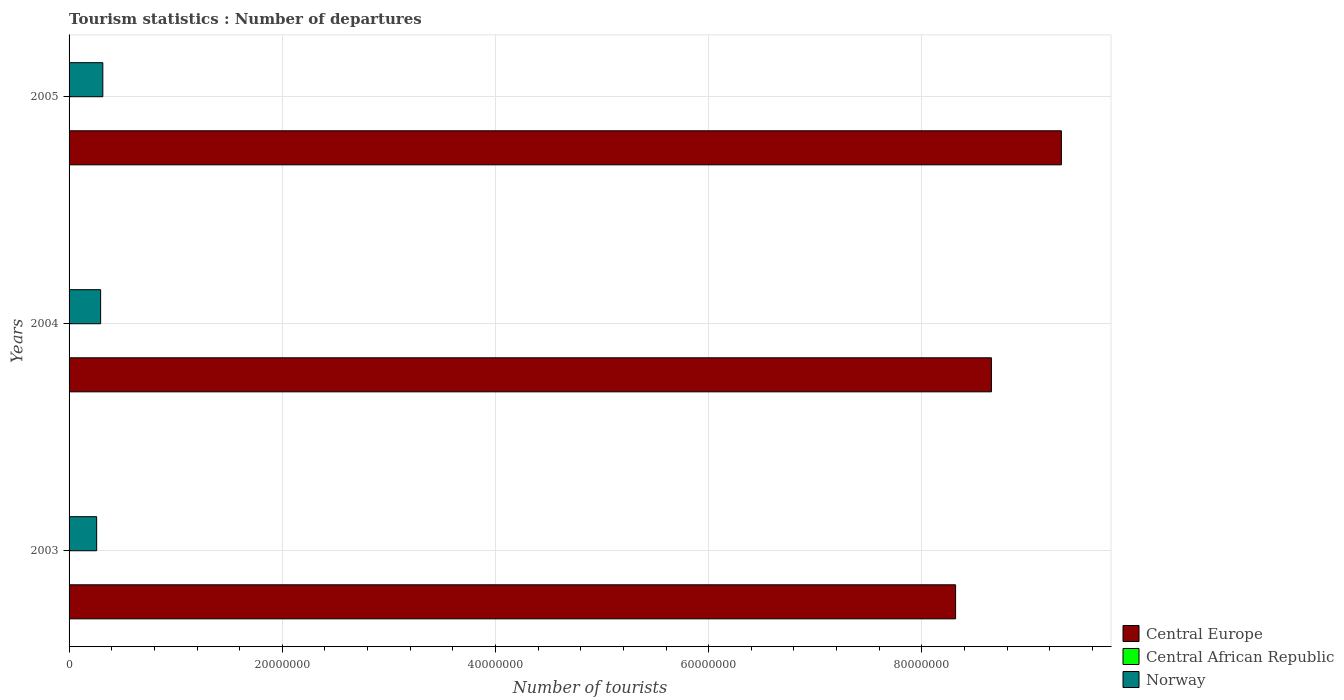Are the number of bars per tick equal to the number of legend labels?
Give a very brief answer. Yes. How many bars are there on the 3rd tick from the bottom?
Keep it short and to the point. 3. What is the label of the 3rd group of bars from the top?
Provide a succinct answer. 2003. In how many cases, is the number of bars for a given year not equal to the number of legend labels?
Your answer should be compact. 0. What is the number of tourist departures in Norway in 2005?
Give a very brief answer. 3.17e+06. Across all years, what is the maximum number of tourist departures in Central Europe?
Ensure brevity in your answer.  9.31e+07. Across all years, what is the minimum number of tourist departures in Central African Republic?
Your answer should be very brief. 6000. What is the total number of tourist departures in Norway in the graph?
Your response must be concise. 8.71e+06. What is the difference between the number of tourist departures in Central Europe in 2004 and that in 2005?
Offer a very short reply. -6.56e+06. What is the difference between the number of tourist departures in Central Europe in 2004 and the number of tourist departures in Central African Republic in 2003?
Your response must be concise. 8.65e+07. What is the average number of tourist departures in Central Europe per year?
Provide a short and direct response. 8.76e+07. In the year 2005, what is the difference between the number of tourist departures in Norway and number of tourist departures in Central Europe?
Provide a short and direct response. -8.99e+07. In how many years, is the number of tourist departures in Norway greater than 80000000 ?
Offer a terse response. 0. Is the number of tourist departures in Central African Republic in 2004 less than that in 2005?
Make the answer very short. Yes. What is the difference between the highest and the second highest number of tourist departures in Norway?
Ensure brevity in your answer.  2.06e+05. What is the difference between the highest and the lowest number of tourist departures in Central Europe?
Provide a succinct answer. 9.92e+06. What does the 2nd bar from the bottom in 2004 represents?
Offer a very short reply. Central African Republic. Is it the case that in every year, the sum of the number of tourist departures in Central Europe and number of tourist departures in Norway is greater than the number of tourist departures in Central African Republic?
Your answer should be very brief. Yes. How many bars are there?
Make the answer very short. 9. Are all the bars in the graph horizontal?
Provide a short and direct response. Yes. How many years are there in the graph?
Your response must be concise. 3. Are the values on the major ticks of X-axis written in scientific E-notation?
Your answer should be compact. No. Where does the legend appear in the graph?
Offer a terse response. Bottom right. What is the title of the graph?
Your answer should be very brief. Tourism statistics : Number of departures. Does "Guam" appear as one of the legend labels in the graph?
Provide a succinct answer. No. What is the label or title of the X-axis?
Offer a terse response. Number of tourists. What is the label or title of the Y-axis?
Provide a succinct answer. Years. What is the Number of tourists of Central Europe in 2003?
Ensure brevity in your answer.  8.32e+07. What is the Number of tourists of Central African Republic in 2003?
Provide a short and direct response. 6000. What is the Number of tourists of Norway in 2003?
Offer a very short reply. 2.59e+06. What is the Number of tourists of Central Europe in 2004?
Your answer should be very brief. 8.65e+07. What is the Number of tourists of Central African Republic in 2004?
Offer a very short reply. 7000. What is the Number of tourists of Norway in 2004?
Ensure brevity in your answer.  2.96e+06. What is the Number of tourists in Central Europe in 2005?
Your response must be concise. 9.31e+07. What is the Number of tourists of Central African Republic in 2005?
Your answer should be compact. 8000. What is the Number of tourists of Norway in 2005?
Provide a short and direct response. 3.17e+06. Across all years, what is the maximum Number of tourists in Central Europe?
Ensure brevity in your answer.  9.31e+07. Across all years, what is the maximum Number of tourists of Central African Republic?
Your answer should be compact. 8000. Across all years, what is the maximum Number of tourists in Norway?
Provide a succinct answer. 3.17e+06. Across all years, what is the minimum Number of tourists in Central Europe?
Your answer should be compact. 8.32e+07. Across all years, what is the minimum Number of tourists in Central African Republic?
Offer a terse response. 6000. Across all years, what is the minimum Number of tourists of Norway?
Ensure brevity in your answer.  2.59e+06. What is the total Number of tourists of Central Europe in the graph?
Your response must be concise. 2.63e+08. What is the total Number of tourists of Central African Republic in the graph?
Offer a terse response. 2.10e+04. What is the total Number of tourists of Norway in the graph?
Provide a short and direct response. 8.71e+06. What is the difference between the Number of tourists of Central Europe in 2003 and that in 2004?
Your response must be concise. -3.36e+06. What is the difference between the Number of tourists of Central African Republic in 2003 and that in 2004?
Offer a terse response. -1000. What is the difference between the Number of tourists of Norway in 2003 and that in 2004?
Offer a terse response. -3.72e+05. What is the difference between the Number of tourists of Central Europe in 2003 and that in 2005?
Offer a very short reply. -9.92e+06. What is the difference between the Number of tourists of Central African Republic in 2003 and that in 2005?
Give a very brief answer. -2000. What is the difference between the Number of tourists in Norway in 2003 and that in 2005?
Make the answer very short. -5.78e+05. What is the difference between the Number of tourists of Central Europe in 2004 and that in 2005?
Provide a succinct answer. -6.56e+06. What is the difference between the Number of tourists of Central African Republic in 2004 and that in 2005?
Your answer should be very brief. -1000. What is the difference between the Number of tourists in Norway in 2004 and that in 2005?
Offer a very short reply. -2.06e+05. What is the difference between the Number of tourists in Central Europe in 2003 and the Number of tourists in Central African Republic in 2004?
Your answer should be compact. 8.32e+07. What is the difference between the Number of tourists of Central Europe in 2003 and the Number of tourists of Norway in 2004?
Your response must be concise. 8.02e+07. What is the difference between the Number of tourists of Central African Republic in 2003 and the Number of tourists of Norway in 2004?
Your answer should be very brief. -2.95e+06. What is the difference between the Number of tourists in Central Europe in 2003 and the Number of tourists in Central African Republic in 2005?
Give a very brief answer. 8.32e+07. What is the difference between the Number of tourists in Central Europe in 2003 and the Number of tourists in Norway in 2005?
Offer a terse response. 8.00e+07. What is the difference between the Number of tourists of Central African Republic in 2003 and the Number of tourists of Norway in 2005?
Offer a terse response. -3.16e+06. What is the difference between the Number of tourists of Central Europe in 2004 and the Number of tourists of Central African Republic in 2005?
Your answer should be very brief. 8.65e+07. What is the difference between the Number of tourists of Central Europe in 2004 and the Number of tourists of Norway in 2005?
Your response must be concise. 8.34e+07. What is the difference between the Number of tourists of Central African Republic in 2004 and the Number of tourists of Norway in 2005?
Ensure brevity in your answer.  -3.16e+06. What is the average Number of tourists of Central Europe per year?
Give a very brief answer. 8.76e+07. What is the average Number of tourists in Central African Republic per year?
Offer a very short reply. 7000. What is the average Number of tourists of Norway per year?
Provide a short and direct response. 2.90e+06. In the year 2003, what is the difference between the Number of tourists in Central Europe and Number of tourists in Central African Republic?
Your response must be concise. 8.32e+07. In the year 2003, what is the difference between the Number of tourists in Central Europe and Number of tourists in Norway?
Offer a terse response. 8.06e+07. In the year 2003, what is the difference between the Number of tourists in Central African Republic and Number of tourists in Norway?
Your answer should be compact. -2.58e+06. In the year 2004, what is the difference between the Number of tourists of Central Europe and Number of tourists of Central African Republic?
Your response must be concise. 8.65e+07. In the year 2004, what is the difference between the Number of tourists in Central Europe and Number of tourists in Norway?
Your answer should be very brief. 8.36e+07. In the year 2004, what is the difference between the Number of tourists in Central African Republic and Number of tourists in Norway?
Offer a terse response. -2.95e+06. In the year 2005, what is the difference between the Number of tourists in Central Europe and Number of tourists in Central African Republic?
Provide a short and direct response. 9.31e+07. In the year 2005, what is the difference between the Number of tourists of Central Europe and Number of tourists of Norway?
Your answer should be very brief. 8.99e+07. In the year 2005, what is the difference between the Number of tourists in Central African Republic and Number of tourists in Norway?
Keep it short and to the point. -3.16e+06. What is the ratio of the Number of tourists of Central Europe in 2003 to that in 2004?
Offer a very short reply. 0.96. What is the ratio of the Number of tourists in Central African Republic in 2003 to that in 2004?
Ensure brevity in your answer.  0.86. What is the ratio of the Number of tourists in Norway in 2003 to that in 2004?
Ensure brevity in your answer.  0.87. What is the ratio of the Number of tourists of Central Europe in 2003 to that in 2005?
Keep it short and to the point. 0.89. What is the ratio of the Number of tourists in Central African Republic in 2003 to that in 2005?
Give a very brief answer. 0.75. What is the ratio of the Number of tourists in Norway in 2003 to that in 2005?
Provide a short and direct response. 0.82. What is the ratio of the Number of tourists in Central Europe in 2004 to that in 2005?
Your response must be concise. 0.93. What is the ratio of the Number of tourists of Norway in 2004 to that in 2005?
Offer a terse response. 0.93. What is the difference between the highest and the second highest Number of tourists in Central Europe?
Make the answer very short. 6.56e+06. What is the difference between the highest and the second highest Number of tourists in Central African Republic?
Your response must be concise. 1000. What is the difference between the highest and the second highest Number of tourists in Norway?
Keep it short and to the point. 2.06e+05. What is the difference between the highest and the lowest Number of tourists of Central Europe?
Give a very brief answer. 9.92e+06. What is the difference between the highest and the lowest Number of tourists in Central African Republic?
Ensure brevity in your answer.  2000. What is the difference between the highest and the lowest Number of tourists in Norway?
Keep it short and to the point. 5.78e+05. 